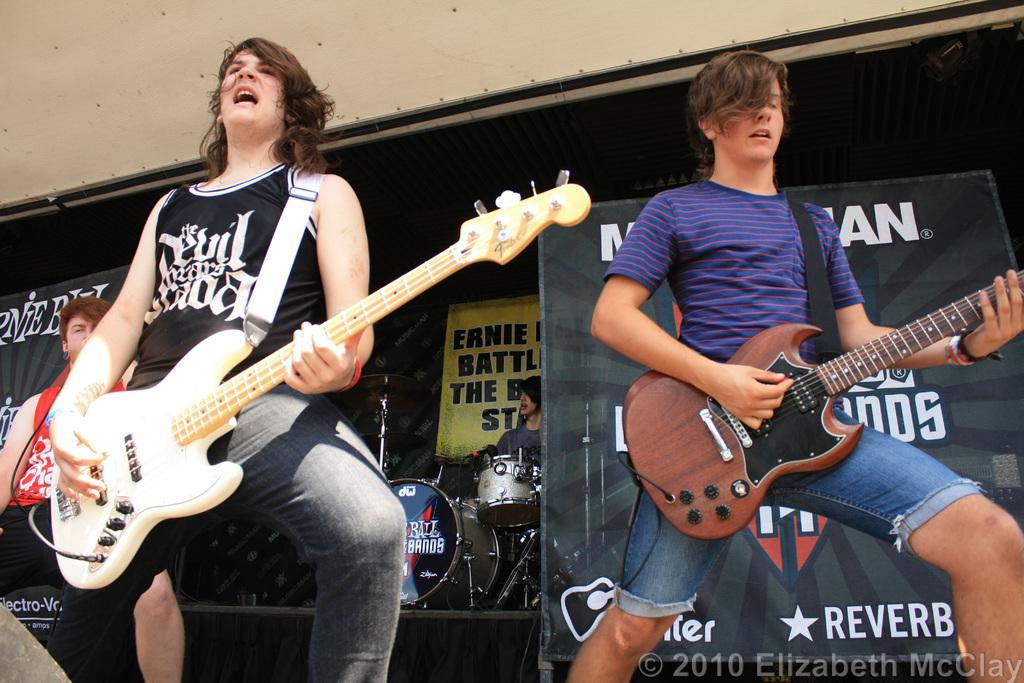Can you describe this image briefly? In this image i can see a person holding the guitar and playing a music and backside there is hoarding and on hoarding there is some text written on that and back side of the hoarding there a person playing a drum and on the left side there is a person stand wearing a red color t-shirt. 